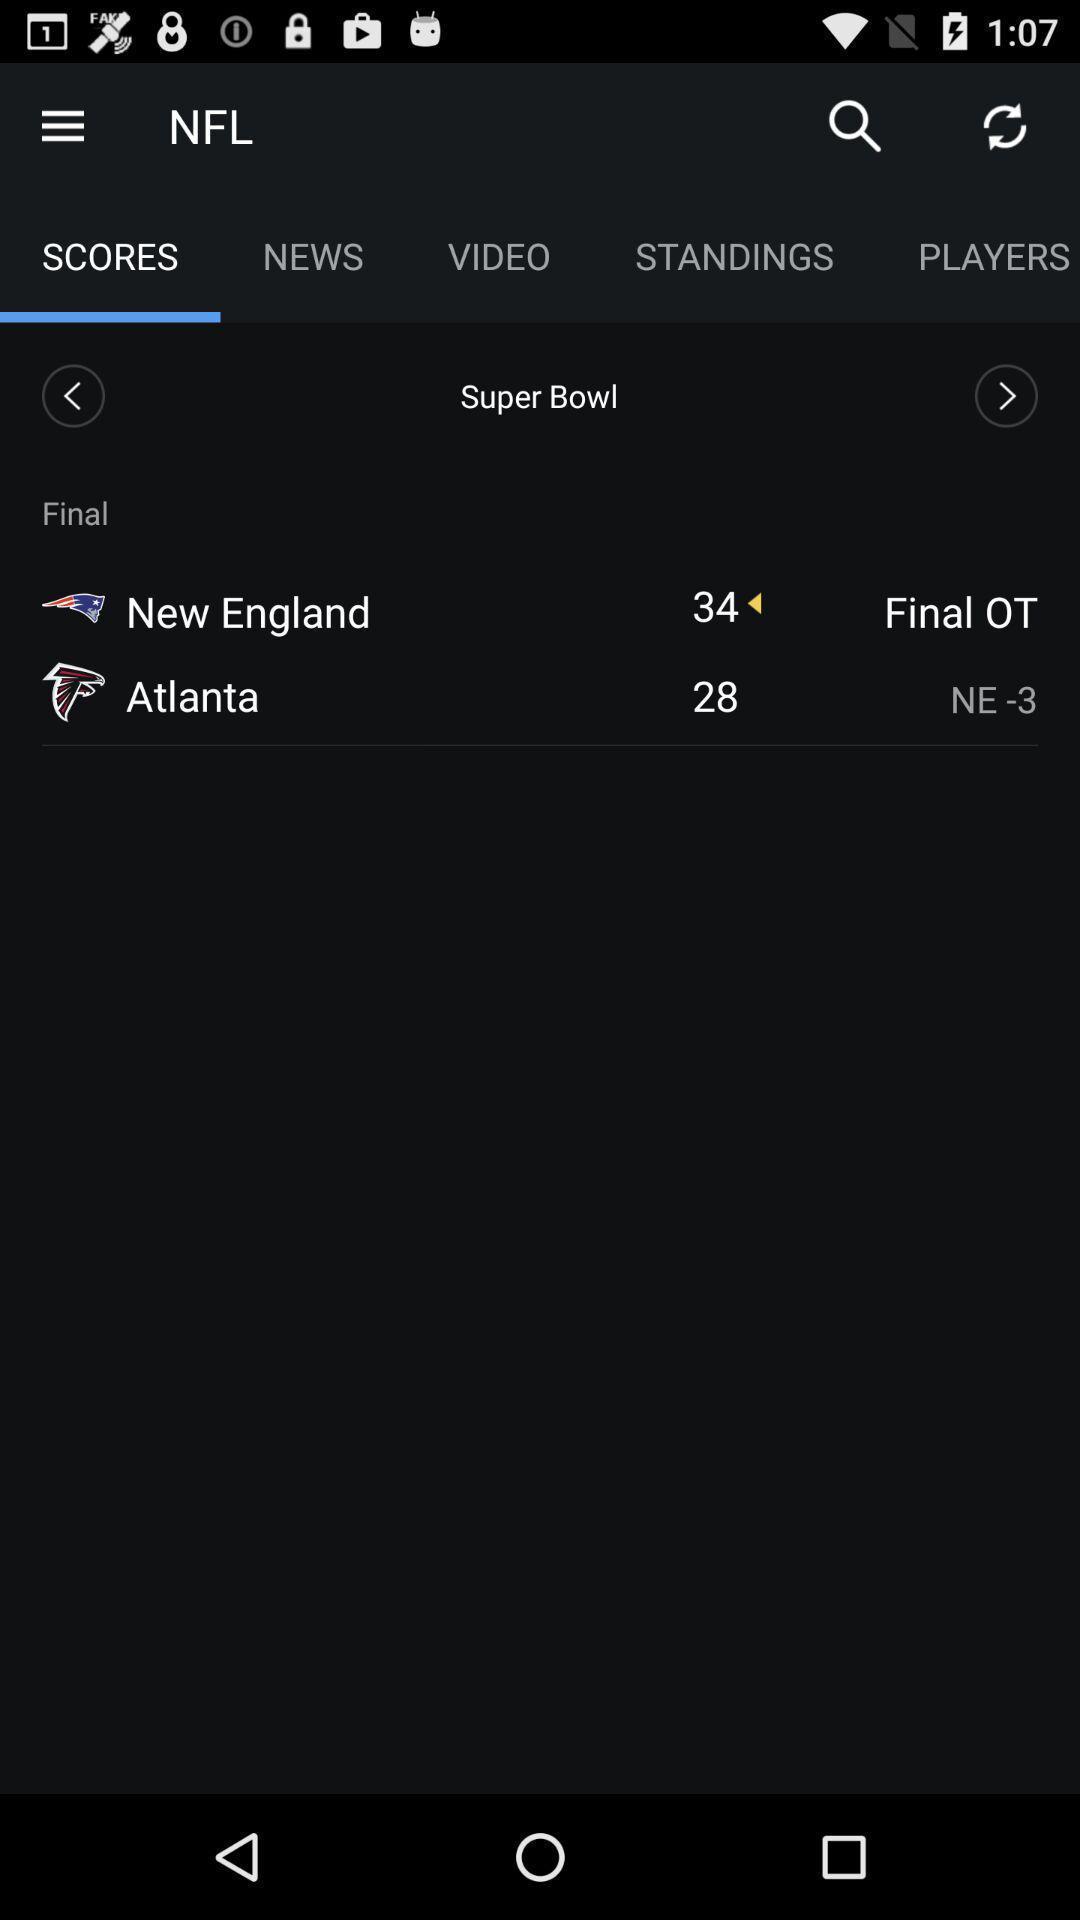Describe the content in this image. Scores displayed of a game in a sports app. 